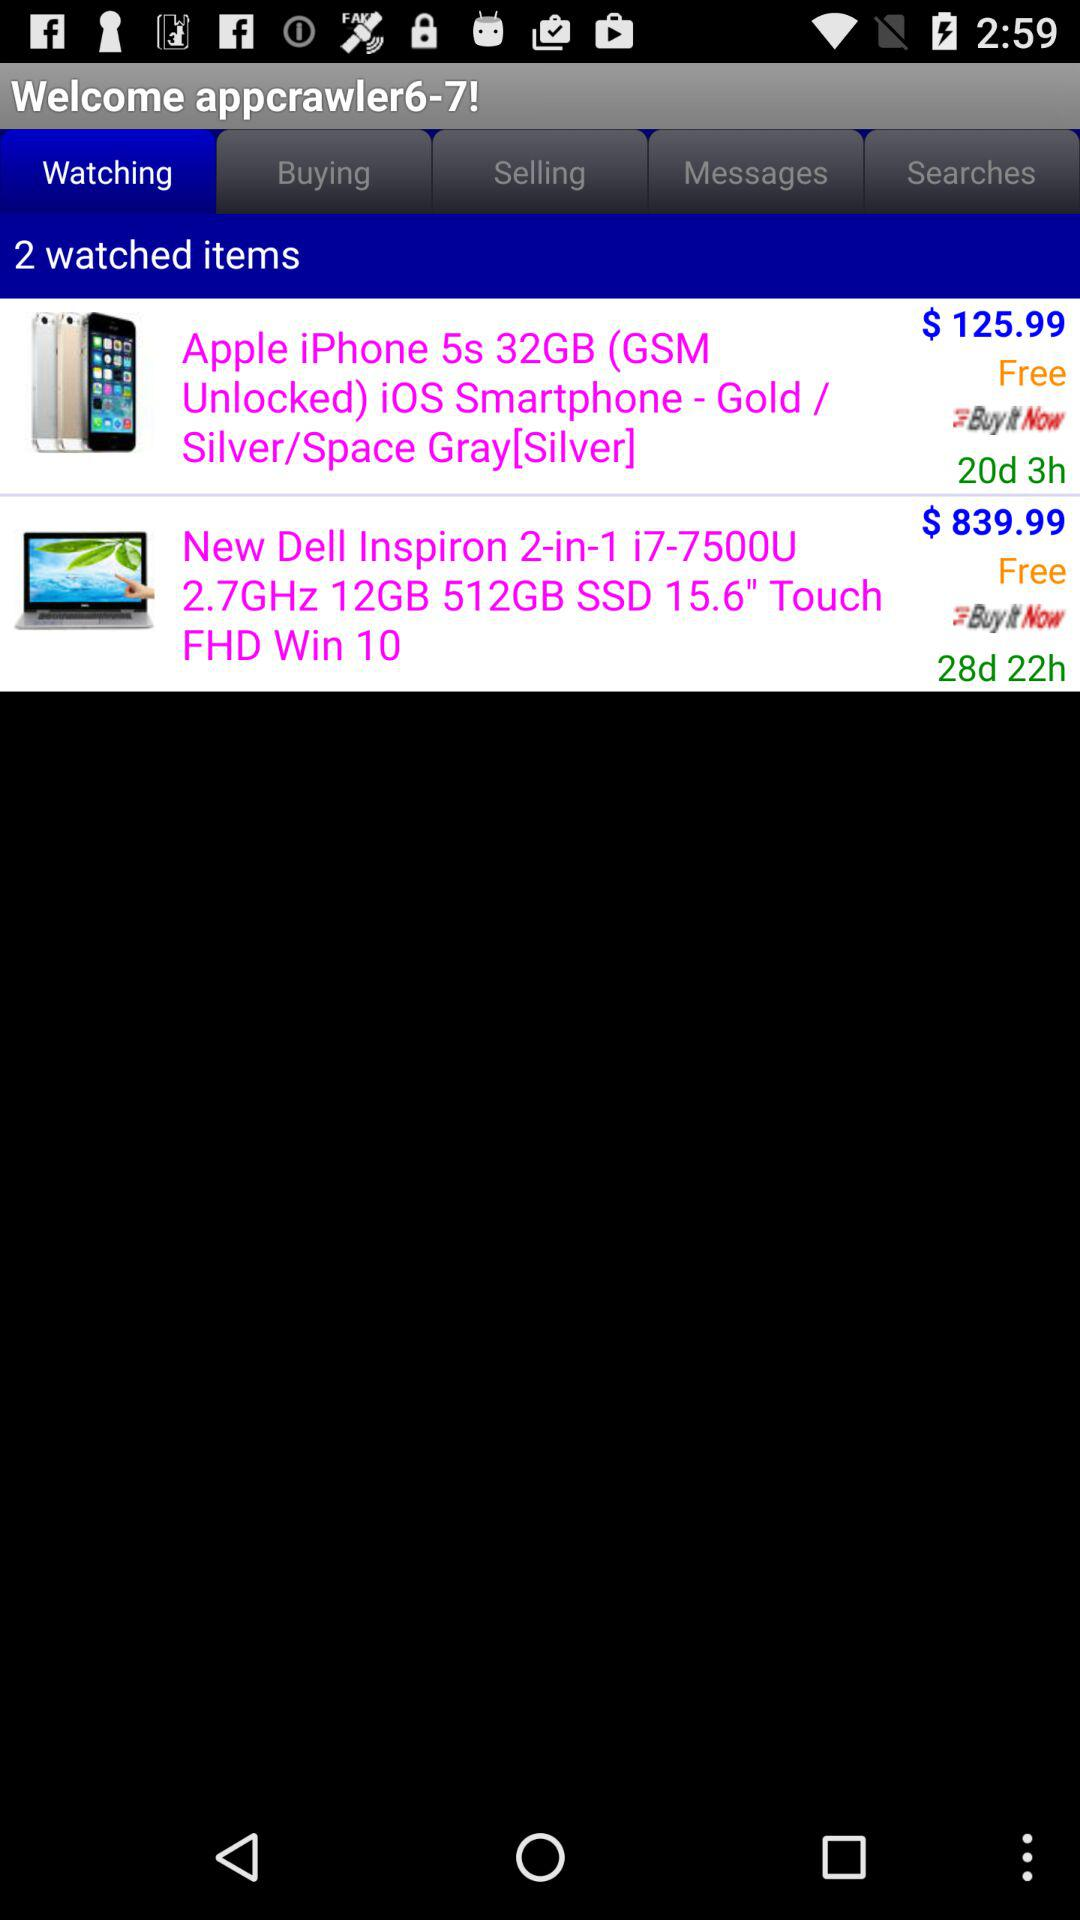How many items were in the watched option? There were 2 items. 